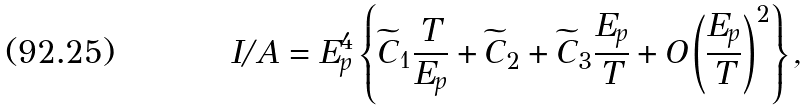<formula> <loc_0><loc_0><loc_500><loc_500>I / A = E _ { p } ^ { 4 } \left \{ \widetilde { C } _ { 1 } \frac { T } { E _ { p } } + \widetilde { C } _ { 2 } + \widetilde { C } _ { 3 } \frac { E _ { p } } { T } + O \left ( \frac { E _ { p } } { T } \right ) ^ { 2 } \right \} ,</formula> 